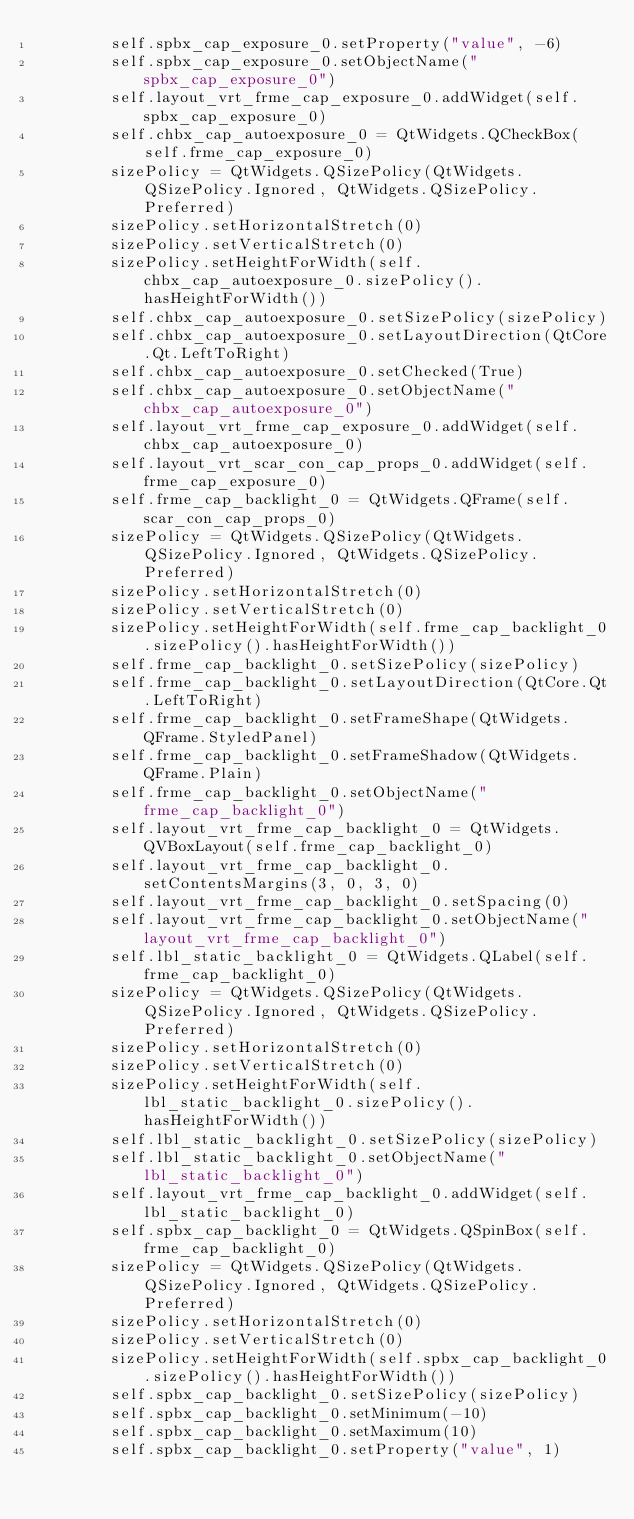Convert code to text. <code><loc_0><loc_0><loc_500><loc_500><_Python_>        self.spbx_cap_exposure_0.setProperty("value", -6)
        self.spbx_cap_exposure_0.setObjectName("spbx_cap_exposure_0")
        self.layout_vrt_frme_cap_exposure_0.addWidget(self.spbx_cap_exposure_0)
        self.chbx_cap_autoexposure_0 = QtWidgets.QCheckBox(self.frme_cap_exposure_0)
        sizePolicy = QtWidgets.QSizePolicy(QtWidgets.QSizePolicy.Ignored, QtWidgets.QSizePolicy.Preferred)
        sizePolicy.setHorizontalStretch(0)
        sizePolicy.setVerticalStretch(0)
        sizePolicy.setHeightForWidth(self.chbx_cap_autoexposure_0.sizePolicy().hasHeightForWidth())
        self.chbx_cap_autoexposure_0.setSizePolicy(sizePolicy)
        self.chbx_cap_autoexposure_0.setLayoutDirection(QtCore.Qt.LeftToRight)
        self.chbx_cap_autoexposure_0.setChecked(True)
        self.chbx_cap_autoexposure_0.setObjectName("chbx_cap_autoexposure_0")
        self.layout_vrt_frme_cap_exposure_0.addWidget(self.chbx_cap_autoexposure_0)
        self.layout_vrt_scar_con_cap_props_0.addWidget(self.frme_cap_exposure_0)
        self.frme_cap_backlight_0 = QtWidgets.QFrame(self.scar_con_cap_props_0)
        sizePolicy = QtWidgets.QSizePolicy(QtWidgets.QSizePolicy.Ignored, QtWidgets.QSizePolicy.Preferred)
        sizePolicy.setHorizontalStretch(0)
        sizePolicy.setVerticalStretch(0)
        sizePolicy.setHeightForWidth(self.frme_cap_backlight_0.sizePolicy().hasHeightForWidth())
        self.frme_cap_backlight_0.setSizePolicy(sizePolicy)
        self.frme_cap_backlight_0.setLayoutDirection(QtCore.Qt.LeftToRight)
        self.frme_cap_backlight_0.setFrameShape(QtWidgets.QFrame.StyledPanel)
        self.frme_cap_backlight_0.setFrameShadow(QtWidgets.QFrame.Plain)
        self.frme_cap_backlight_0.setObjectName("frme_cap_backlight_0")
        self.layout_vrt_frme_cap_backlight_0 = QtWidgets.QVBoxLayout(self.frme_cap_backlight_0)
        self.layout_vrt_frme_cap_backlight_0.setContentsMargins(3, 0, 3, 0)
        self.layout_vrt_frme_cap_backlight_0.setSpacing(0)
        self.layout_vrt_frme_cap_backlight_0.setObjectName("layout_vrt_frme_cap_backlight_0")
        self.lbl_static_backlight_0 = QtWidgets.QLabel(self.frme_cap_backlight_0)
        sizePolicy = QtWidgets.QSizePolicy(QtWidgets.QSizePolicy.Ignored, QtWidgets.QSizePolicy.Preferred)
        sizePolicy.setHorizontalStretch(0)
        sizePolicy.setVerticalStretch(0)
        sizePolicy.setHeightForWidth(self.lbl_static_backlight_0.sizePolicy().hasHeightForWidth())
        self.lbl_static_backlight_0.setSizePolicy(sizePolicy)
        self.lbl_static_backlight_0.setObjectName("lbl_static_backlight_0")
        self.layout_vrt_frme_cap_backlight_0.addWidget(self.lbl_static_backlight_0)
        self.spbx_cap_backlight_0 = QtWidgets.QSpinBox(self.frme_cap_backlight_0)
        sizePolicy = QtWidgets.QSizePolicy(QtWidgets.QSizePolicy.Ignored, QtWidgets.QSizePolicy.Preferred)
        sizePolicy.setHorizontalStretch(0)
        sizePolicy.setVerticalStretch(0)
        sizePolicy.setHeightForWidth(self.spbx_cap_backlight_0.sizePolicy().hasHeightForWidth())
        self.spbx_cap_backlight_0.setSizePolicy(sizePolicy)
        self.spbx_cap_backlight_0.setMinimum(-10)
        self.spbx_cap_backlight_0.setMaximum(10)
        self.spbx_cap_backlight_0.setProperty("value", 1)</code> 